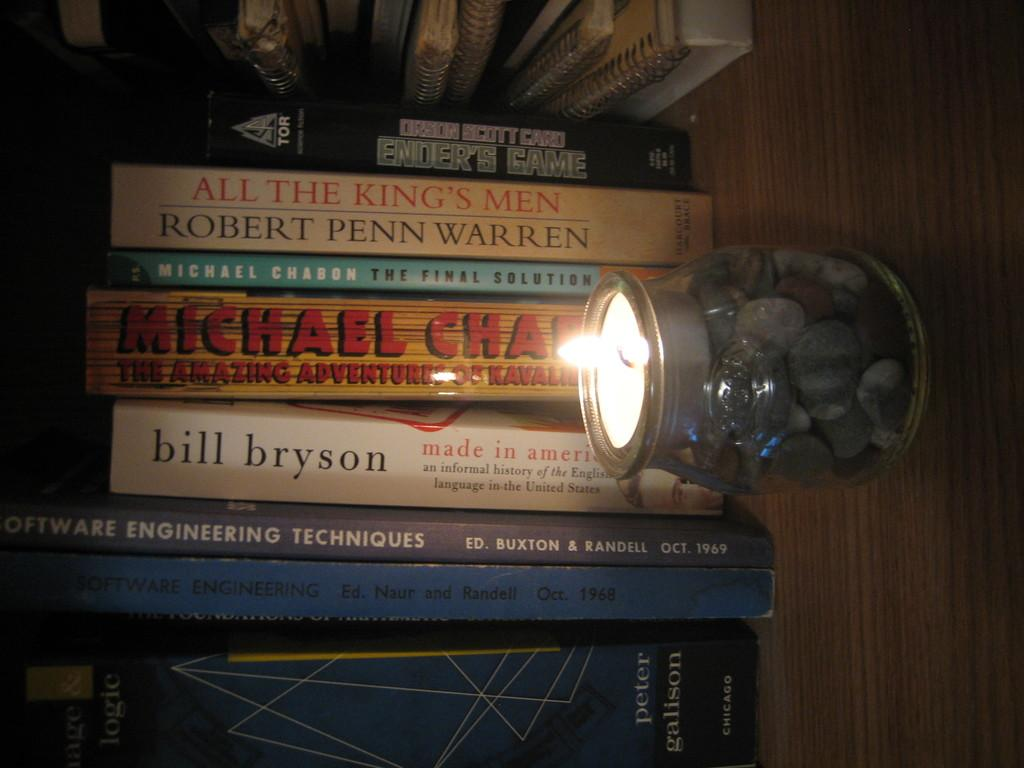<image>
Summarize the visual content of the image. several books, one made by bill bryson called Made in America 